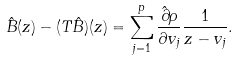<formula> <loc_0><loc_0><loc_500><loc_500>\hat { B } ( z ) - ( T \hat { B } ) ( z ) = \sum _ { j = 1 } ^ { p } \frac { \hat { \partial } \rho } { \partial v _ { j } } \frac { 1 } { z - v _ { j } } .</formula> 